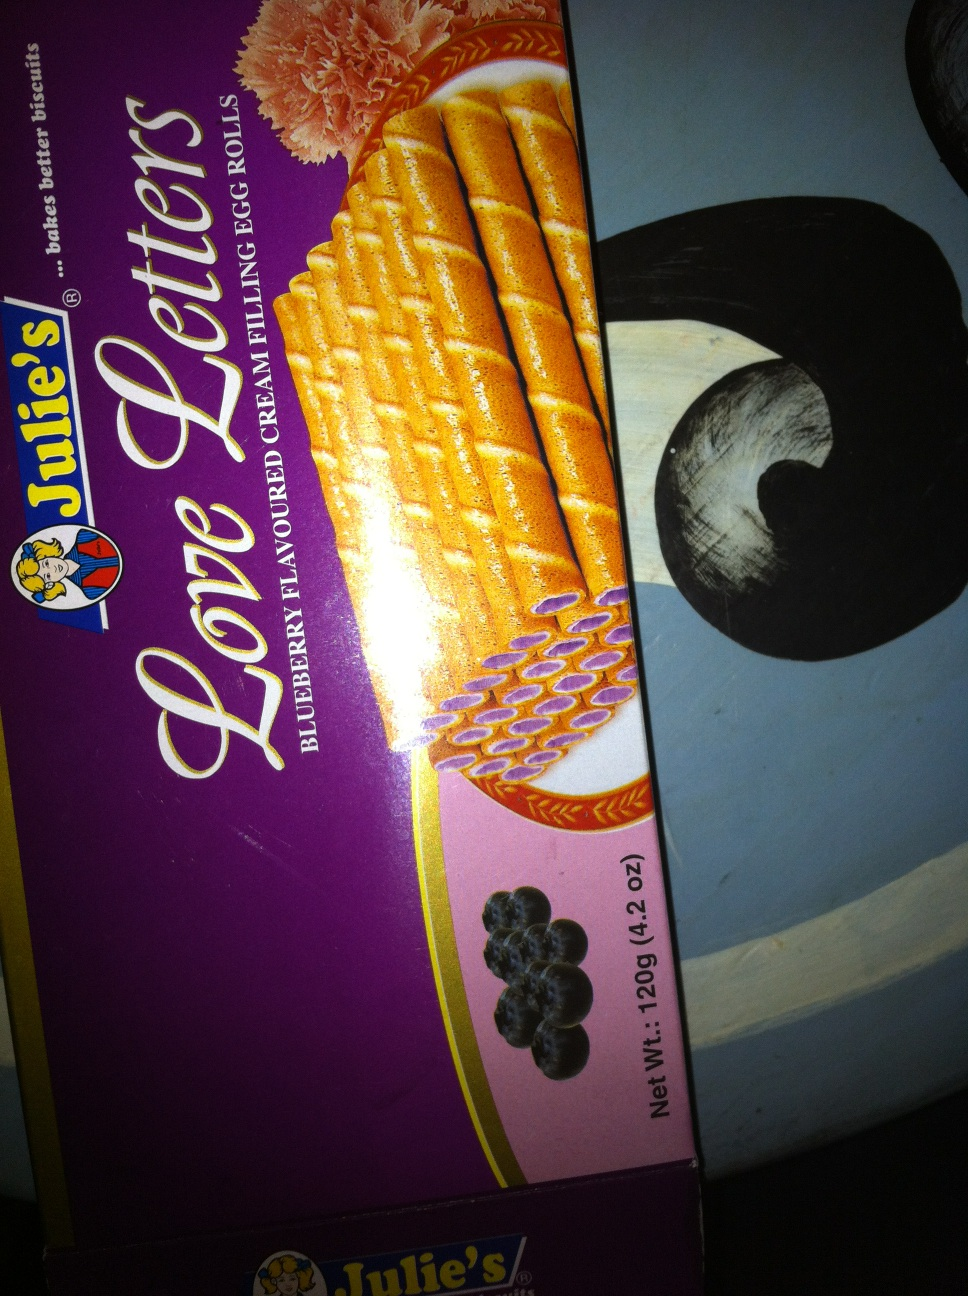What is this box? thank you. from Vizwiz The box in the image is of a product called 'Love Letters', which are cream-filled egg rolls. The specific variety shown here is blueberry flavored, and the product is made by the brand 'Julie's'. Each package weighs 120g (4.2 oz). 